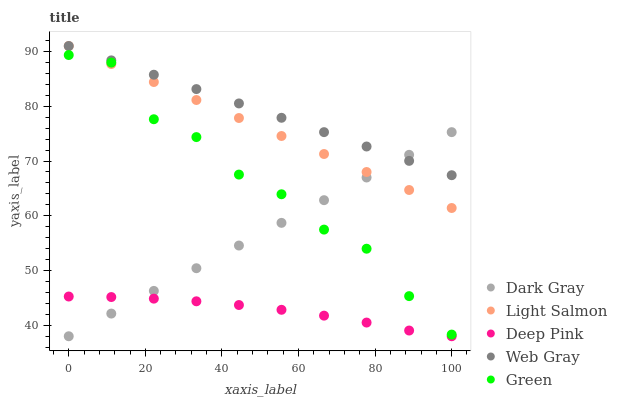Does Deep Pink have the minimum area under the curve?
Answer yes or no. Yes. Does Web Gray have the maximum area under the curve?
Answer yes or no. Yes. Does Green have the minimum area under the curve?
Answer yes or no. No. Does Green have the maximum area under the curve?
Answer yes or no. No. Is Dark Gray the smoothest?
Answer yes or no. Yes. Is Green the roughest?
Answer yes or no. Yes. Is Light Salmon the smoothest?
Answer yes or no. No. Is Light Salmon the roughest?
Answer yes or no. No. Does Dark Gray have the lowest value?
Answer yes or no. Yes. Does Green have the lowest value?
Answer yes or no. No. Does Web Gray have the highest value?
Answer yes or no. Yes. Does Green have the highest value?
Answer yes or no. No. Is Deep Pink less than Web Gray?
Answer yes or no. Yes. Is Web Gray greater than Deep Pink?
Answer yes or no. Yes. Does Light Salmon intersect Dark Gray?
Answer yes or no. Yes. Is Light Salmon less than Dark Gray?
Answer yes or no. No. Is Light Salmon greater than Dark Gray?
Answer yes or no. No. Does Deep Pink intersect Web Gray?
Answer yes or no. No. 